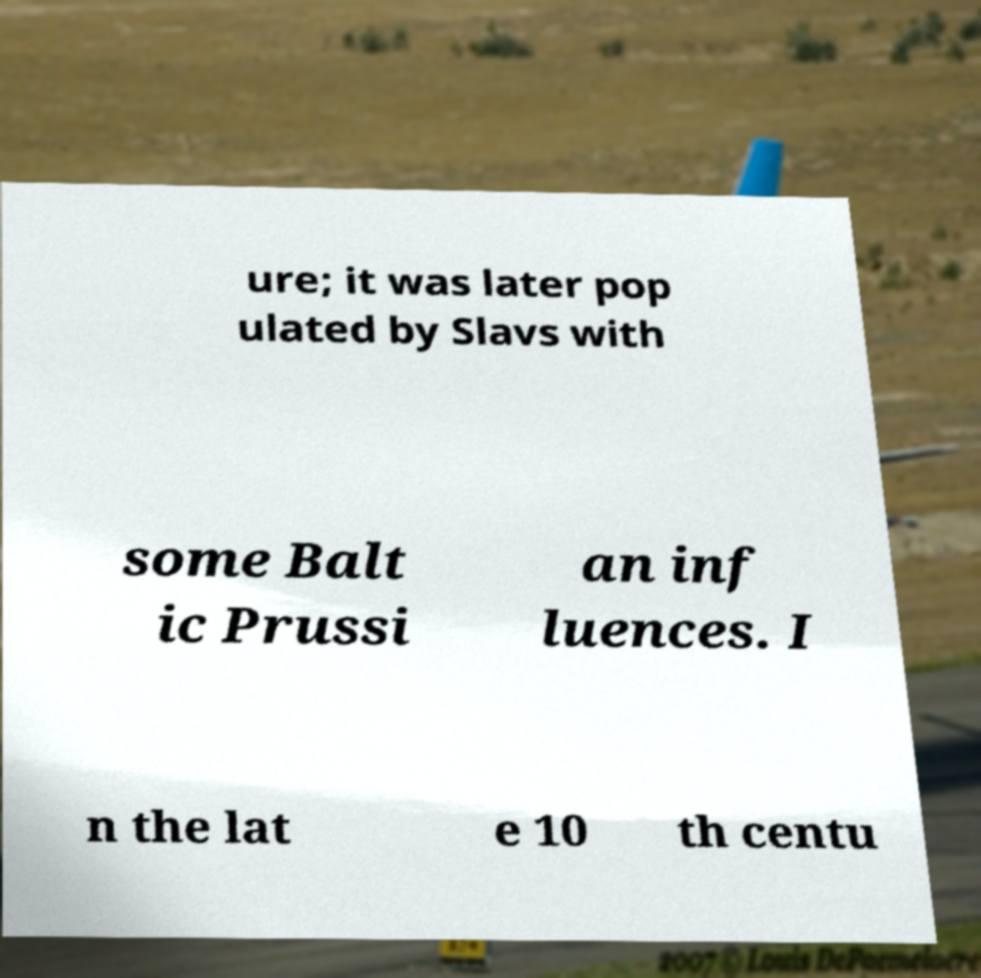Could you assist in decoding the text presented in this image and type it out clearly? ure; it was later pop ulated by Slavs with some Balt ic Prussi an inf luences. I n the lat e 10 th centu 